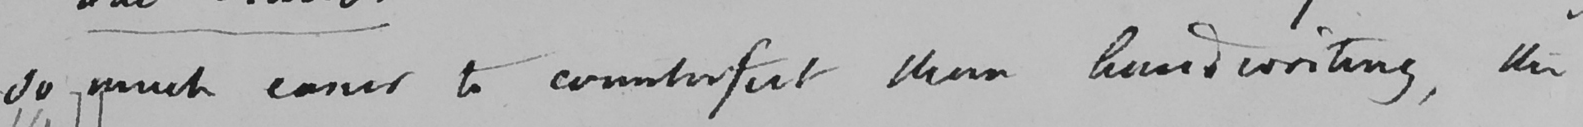What is written in this line of handwriting? so much easier to counterfeit than handwriting , the 